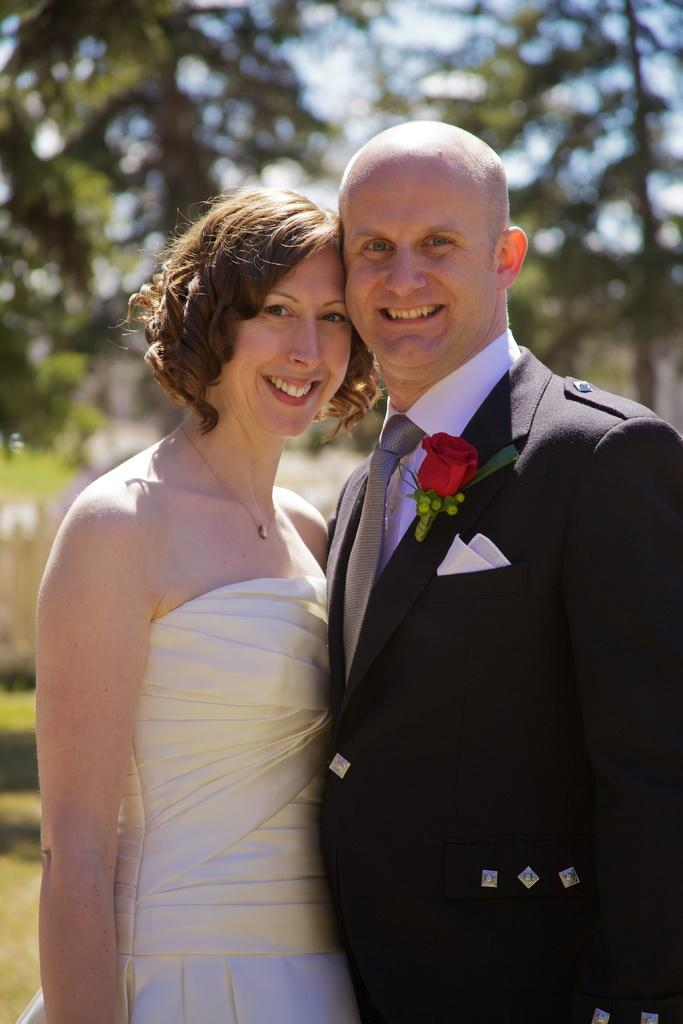Who are the people in the image? There is a man and a woman in the image. What is the surface they are standing on? They are standing on the ground. What can be seen in the background of the image? There is grass, trees, and the sky visible in the background of the image. What type of rock is the fireman using to extinguish the fire in the image? There is no fireman or fire present in the image, so it is not possible to answer that question. 